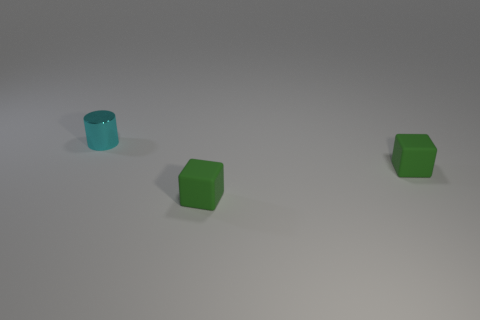What colors are the cubes in the image? The cubes in the image are green. One has a slightly lighter shade than the other, which appears to be due to the lighting in the scene. 